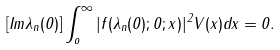<formula> <loc_0><loc_0><loc_500><loc_500>[ I m \lambda _ { n } ( 0 ) ] \int _ { o } ^ { \infty } | f ( \lambda _ { n } ( 0 ) ; 0 ; x ) | ^ { 2 } V ( x ) d x = 0 .</formula> 